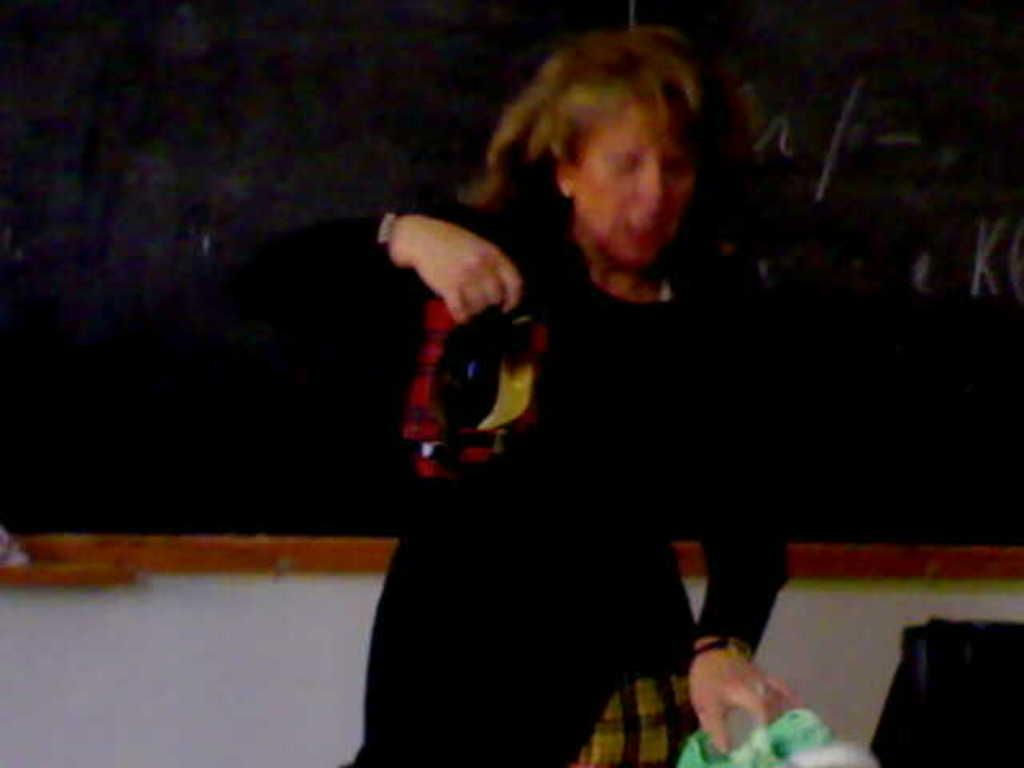Who is present in the image? There is a woman in the image. What is the woman holding in her hand? The woman is holding an object in her hand. What can be seen near the woman? There is a bag in the image. What is visible in the background of the image? There is a wall and a blackboard in the background of the image. What chess move is the woman making in the image? There is no chessboard or chess pieces present in the image, so it is not possible to determine any chess moves. 